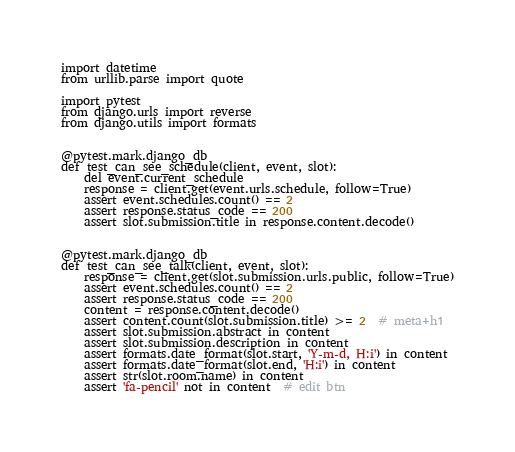<code> <loc_0><loc_0><loc_500><loc_500><_Python_>import datetime
from urllib.parse import quote

import pytest
from django.urls import reverse
from django.utils import formats


@pytest.mark.django_db
def test_can_see_schedule(client, event, slot):
    del event.current_schedule
    response = client.get(event.urls.schedule, follow=True)
    assert event.schedules.count() == 2
    assert response.status_code == 200
    assert slot.submission.title in response.content.decode()


@pytest.mark.django_db
def test_can_see_talk(client, event, slot):
    response = client.get(slot.submission.urls.public, follow=True)
    assert event.schedules.count() == 2
    assert response.status_code == 200
    content = response.content.decode()
    assert content.count(slot.submission.title) >= 2  # meta+h1
    assert slot.submission.abstract in content
    assert slot.submission.description in content
    assert formats.date_format(slot.start, 'Y-m-d, H:i') in content
    assert formats.date_format(slot.end, 'H:i') in content
    assert str(slot.room.name) in content
    assert 'fa-pencil' not in content  # edit btn</code> 